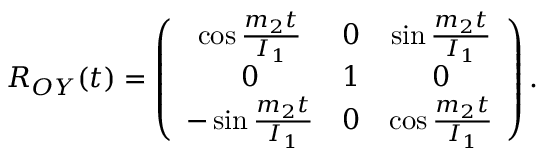<formula> <loc_0><loc_0><loc_500><loc_500>\begin{array} { r } { R _ { O Y } ( t ) = \left ( \begin{array} { c c c } { \cos \frac { m _ { 2 } t } { I _ { 1 } } } & { 0 } & { \sin \frac { m _ { 2 } t } { I _ { 1 } } } \\ { 0 } & { 1 } & { 0 } \\ { - \sin \frac { m _ { 2 } t } { I _ { 1 } } } & { 0 } & { \cos \frac { m _ { 2 } t } { I _ { 1 } } } \end{array} \right ) . } \end{array}</formula> 